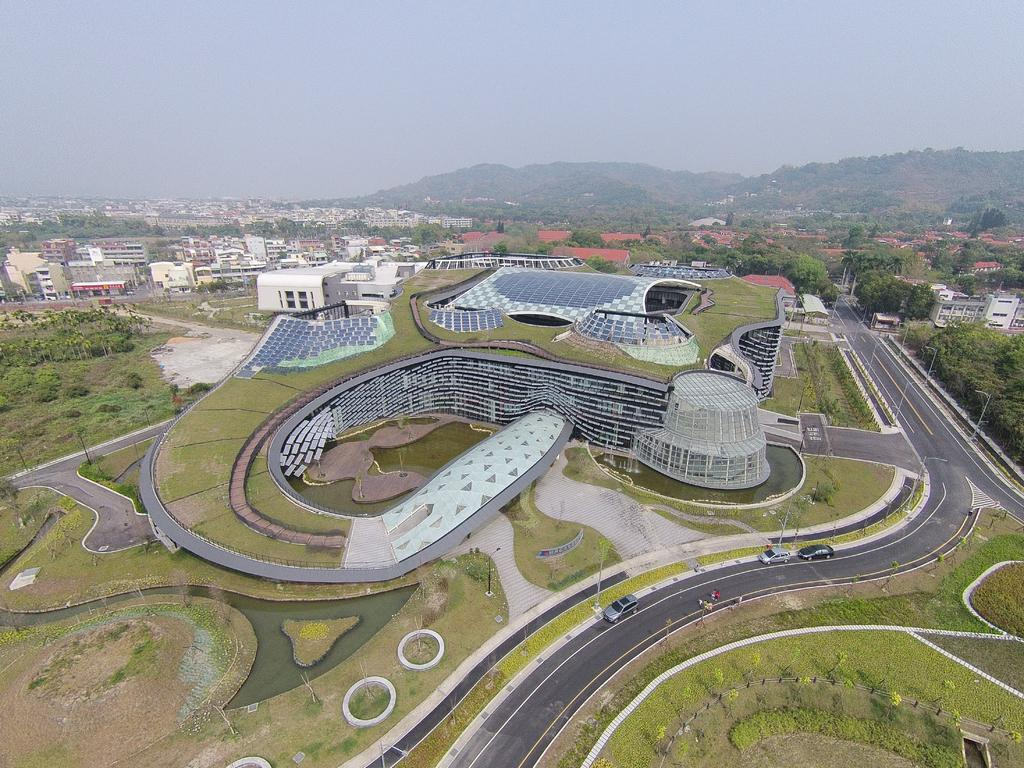What type of view is provided in the image? The image is an aerial view. What can be seen in the image from this perspective? There are many buildings, trees, roads, vehicles, hills, and the sky visible in the image. How are the roads arranged in the image? The roads are visible in the image, connecting various parts of the area. What type of weather can be inferred from the image? The image does not provide information about the weather, but the presence of vehicles suggests that it is not a stormy day. What type of acoustics can be heard in the image? There is no sound present in the image, so it is not possible to determine the acoustics. How many sleet particles are visible on the roads in the image? There is no sleet present in the image, so it is not possible to count sleet particles. 